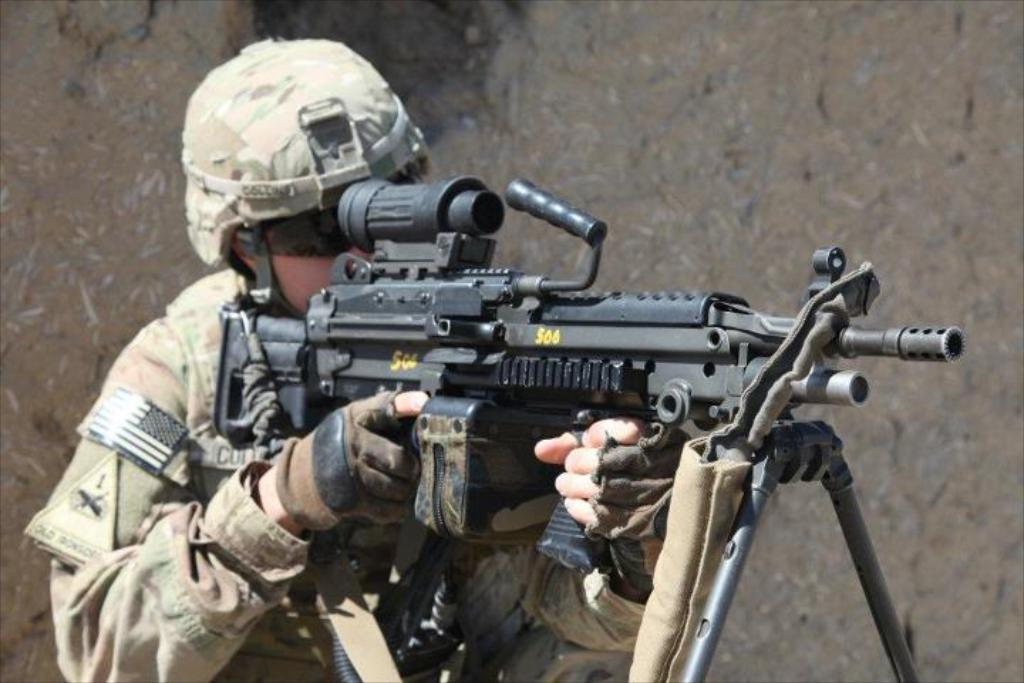What is the main subject of the image? There is a person in the image. What protective gear is the person wearing? The person is wearing gloves and a helmet. What is the person holding in the image? The person is holding a gun. How is the gun positioned in the image? The gun is on a stand. What type of nut is the person trying to crack with the gun in the image? There is no nut present in the image, and the gun is not being used to crack anything. 